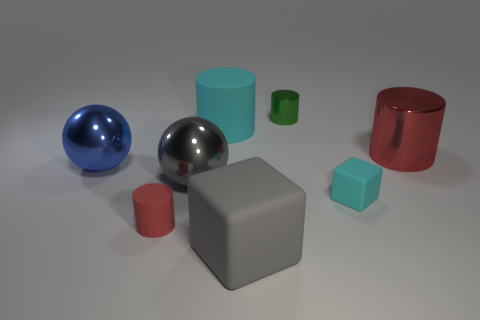Does the big block have the same color as the big metal thing that is in front of the big blue metallic thing?
Ensure brevity in your answer.  Yes. How many shiny balls have the same color as the tiny metal cylinder?
Your answer should be compact. 0. Is there a large gray rubber block right of the large cylinder that is on the left side of the big object in front of the tiny matte block?
Provide a succinct answer. Yes. There is a cylinder that is on the left side of the gray block and behind the tiny rubber block; how big is it?
Keep it short and to the point. Large. How many big blocks have the same material as the big cyan object?
Your response must be concise. 1. How many cylinders are large blue shiny objects or tiny green metallic things?
Provide a short and direct response. 1. How big is the gray metallic object in front of the red cylinder that is on the right side of the cyan object on the left side of the tiny green shiny cylinder?
Ensure brevity in your answer.  Large. What color is the shiny object that is both to the left of the small block and behind the big blue shiny sphere?
Make the answer very short. Green. There is a red rubber object; is its size the same as the gray object that is left of the large cyan rubber cylinder?
Provide a succinct answer. No. Are there any other things that are the same shape as the green thing?
Provide a succinct answer. Yes. 